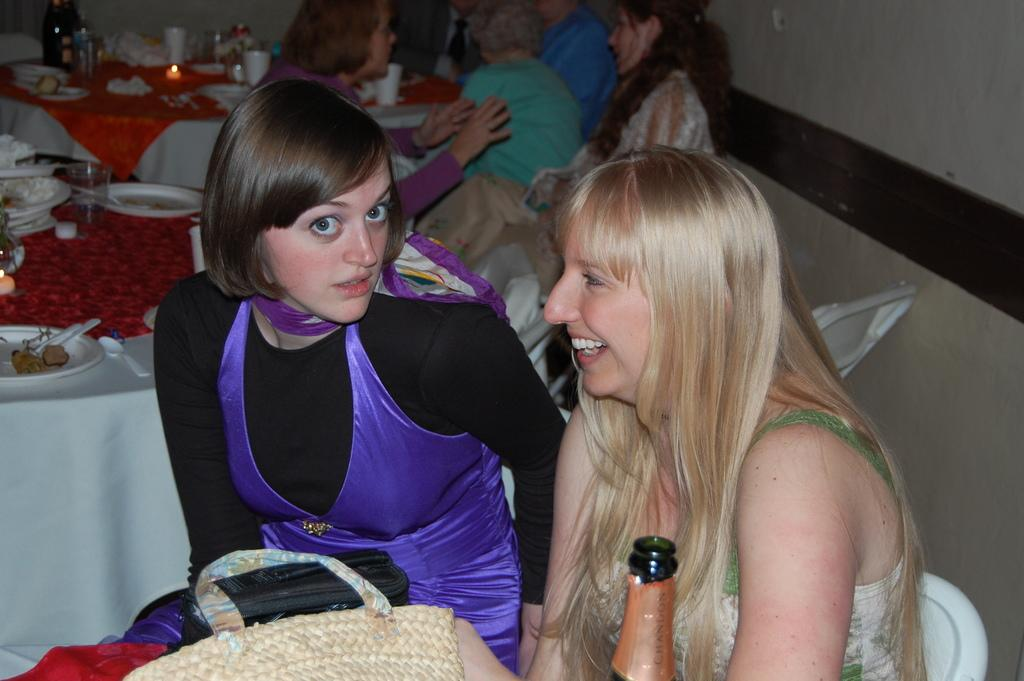What are the women in the image doing? The women are seated in the image. What are the women sitting on? The women are seated on chairs. What can be seen on the tables in the image? There are plates, spoons, and glasses on the tables. What else is present in the image? There is a bottle and a bag in the image. What type of creature is crawling on the table in the image? There is no creature crawling on the table in the image. What is the string used for in the image? There is no string present in the image. 